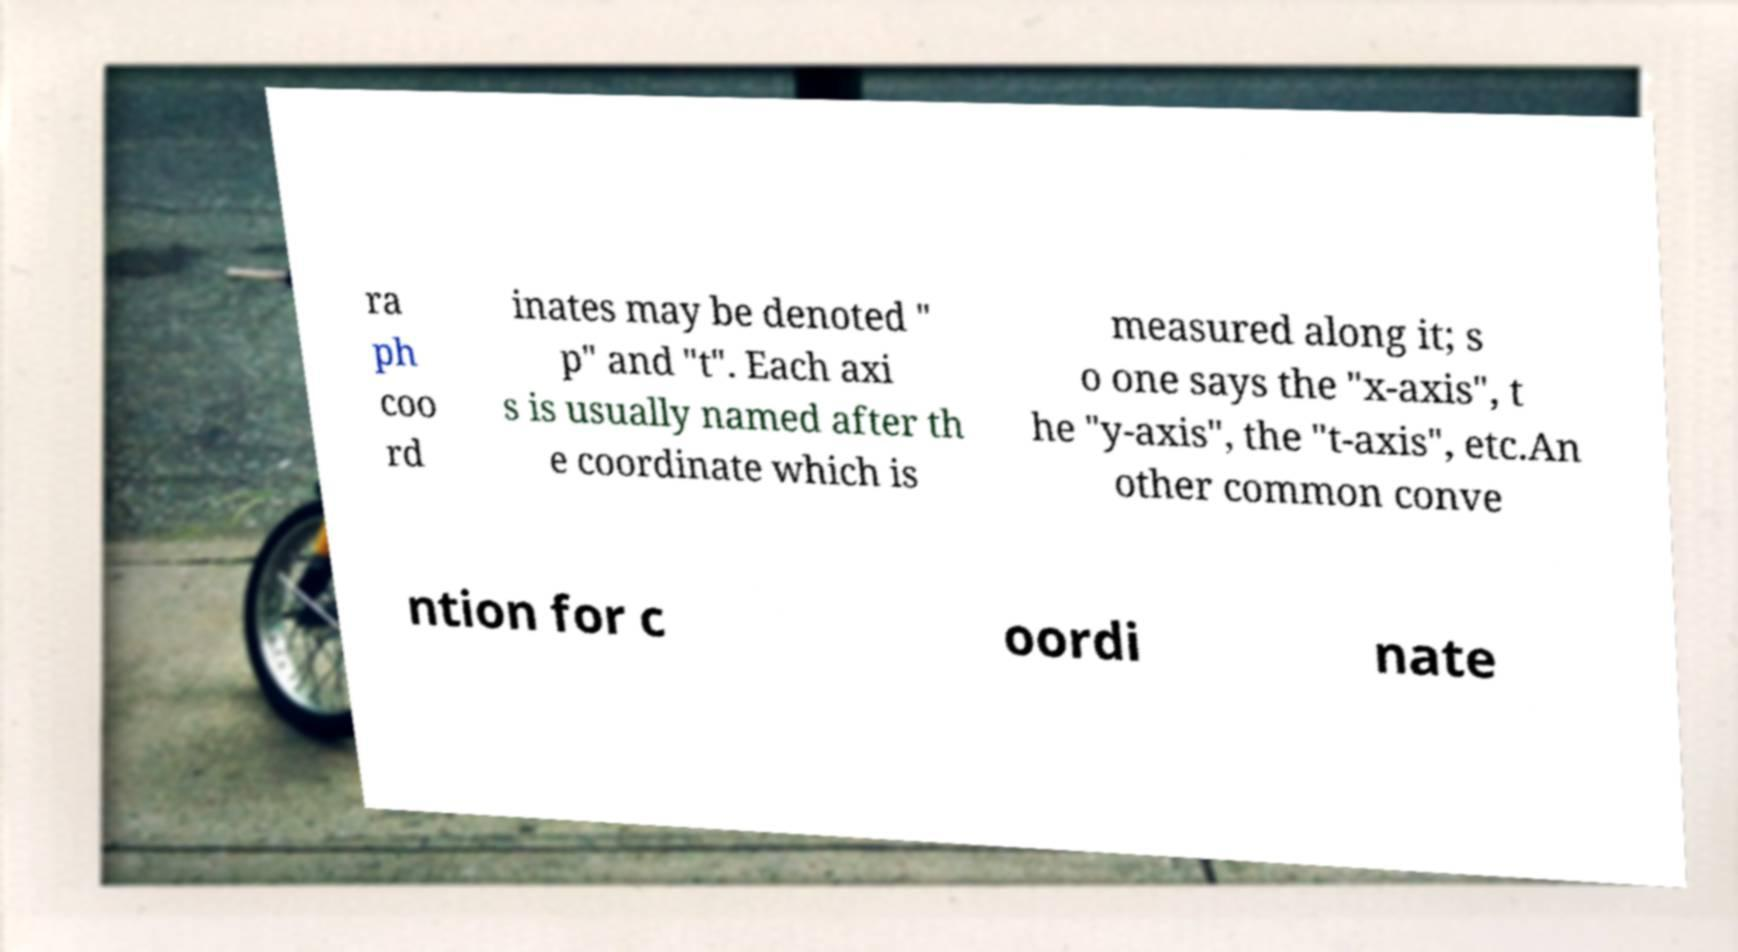I need the written content from this picture converted into text. Can you do that? ra ph coo rd inates may be denoted " p" and "t". Each axi s is usually named after th e coordinate which is measured along it; s o one says the "x-axis", t he "y-axis", the "t-axis", etc.An other common conve ntion for c oordi nate 